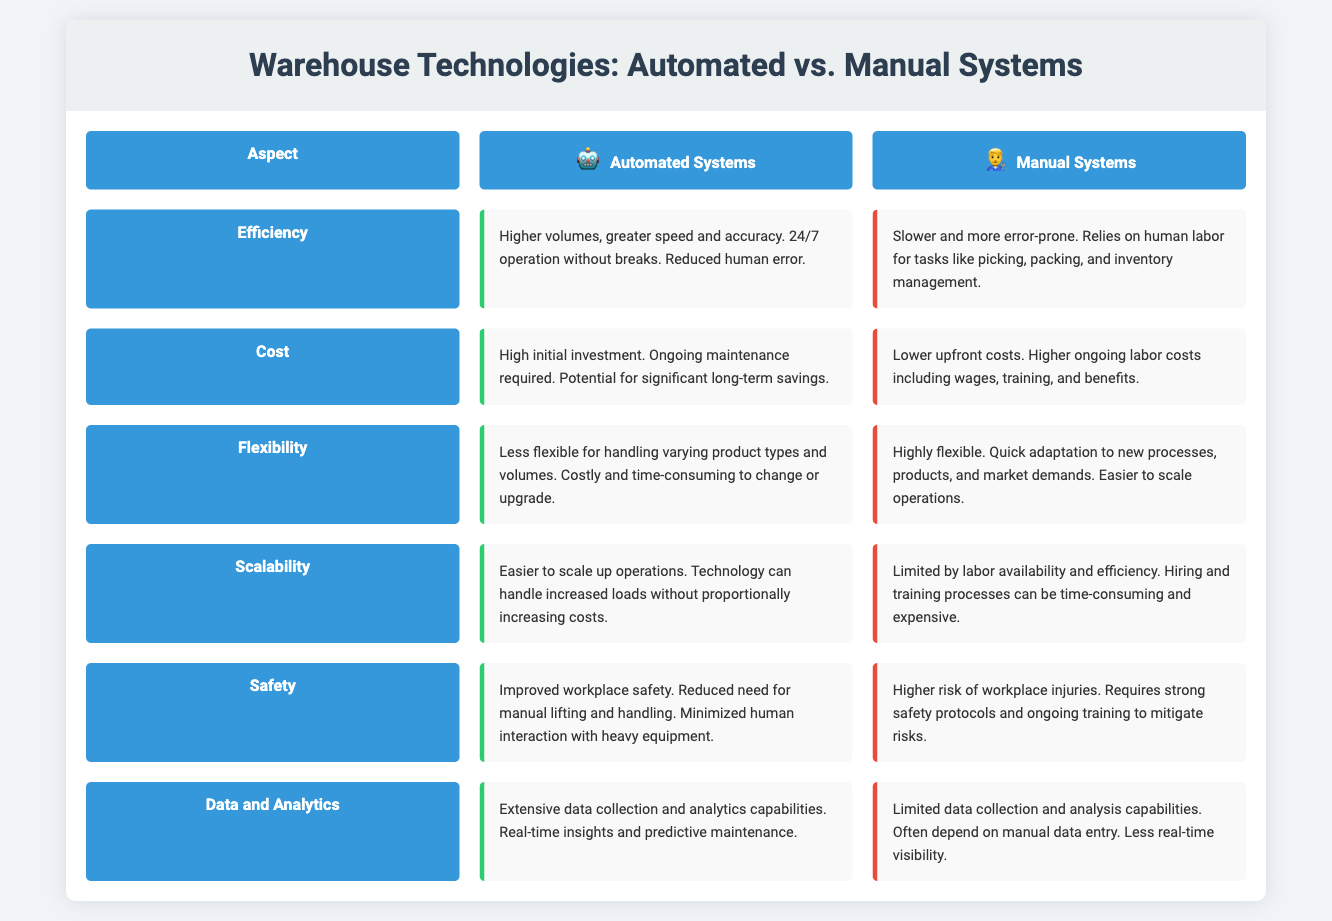What is the main title of the infographic? The title provides a summary of the content and focus of the infographic.
Answer: Warehouse Technologies: Automated vs. Manual Systems What aspect has higher efficiency? The efficiency comparison looks at the performance capabilities of both systems.
Answer: Automated Systems What is the cost implication of automated systems? The cost section outlines financial aspects related to adopting the different systems.
Answer: High initial investment Which system offers greater flexibility? This question looks at how adaptable the systems are in response to changes.
Answer: Manual Systems What safety advantage do automated systems have? The safety aspect highlights the workplace conditions associated with each system.
Answer: Improved workplace safety Which system has limited scalability? Scalability describes the ability to expand operations without proportional cost increases.
Answer: Manual Systems How do automated systems benefit from data analytics? This question relates to how data is utilized in each system for operational improvement.
Answer: Extensive data collection and analytics capabilities What is a drawback of manual systems regarding speed? The question focuses on operational performance related to speed in manual systems.
Answer: Slower and more error-prone 